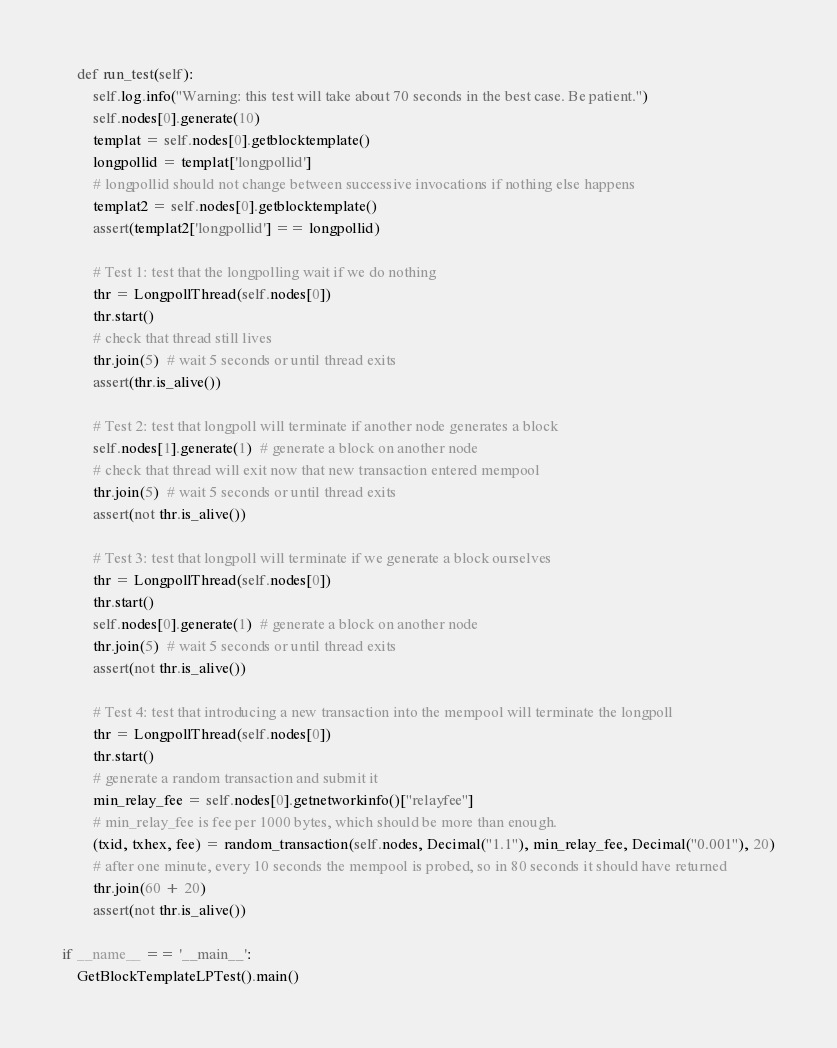Convert code to text. <code><loc_0><loc_0><loc_500><loc_500><_Python_>
    def run_test(self):
        self.log.info("Warning: this test will take about 70 seconds in the best case. Be patient.")
        self.nodes[0].generate(10)
        templat = self.nodes[0].getblocktemplate()
        longpollid = templat['longpollid']
        # longpollid should not change between successive invocations if nothing else happens
        templat2 = self.nodes[0].getblocktemplate()
        assert(templat2['longpollid'] == longpollid)

        # Test 1: test that the longpolling wait if we do nothing
        thr = LongpollThread(self.nodes[0])
        thr.start()
        # check that thread still lives
        thr.join(5)  # wait 5 seconds or until thread exits
        assert(thr.is_alive())

        # Test 2: test that longpoll will terminate if another node generates a block
        self.nodes[1].generate(1)  # generate a block on another node
        # check that thread will exit now that new transaction entered mempool
        thr.join(5)  # wait 5 seconds or until thread exits
        assert(not thr.is_alive())

        # Test 3: test that longpoll will terminate if we generate a block ourselves
        thr = LongpollThread(self.nodes[0])
        thr.start()
        self.nodes[0].generate(1)  # generate a block on another node
        thr.join(5)  # wait 5 seconds or until thread exits
        assert(not thr.is_alive())

        # Test 4: test that introducing a new transaction into the mempool will terminate the longpoll
        thr = LongpollThread(self.nodes[0])
        thr.start()
        # generate a random transaction and submit it
        min_relay_fee = self.nodes[0].getnetworkinfo()["relayfee"]
        # min_relay_fee is fee per 1000 bytes, which should be more than enough.
        (txid, txhex, fee) = random_transaction(self.nodes, Decimal("1.1"), min_relay_fee, Decimal("0.001"), 20)
        # after one minute, every 10 seconds the mempool is probed, so in 80 seconds it should have returned
        thr.join(60 + 20)
        assert(not thr.is_alive())

if __name__ == '__main__':
    GetBlockTemplateLPTest().main()

</code> 